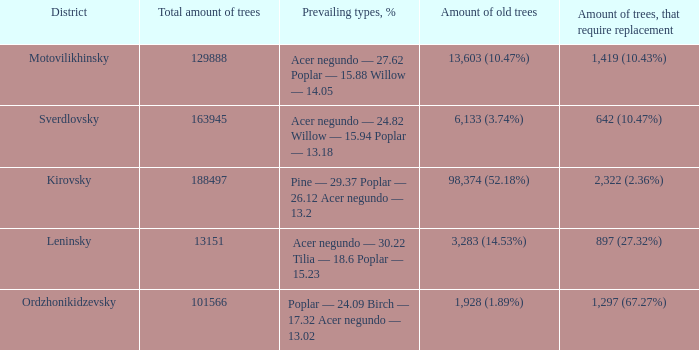Could you parse the entire table as a dict? {'header': ['District', 'Total amount of trees', 'Prevailing types, %', 'Amount of old trees', 'Amount of trees, that require replacement'], 'rows': [['Motovilikhinsky', '129888', 'Acer negundo — 27.62 Poplar — 15.88 Willow — 14.05', '13,603 (10.47%)', '1,419 (10.43%)'], ['Sverdlovsky', '163945', 'Acer negundo — 24.82 Willow — 15.94 Poplar — 13.18', '6,133 (3.74%)', '642 (10.47%)'], ['Kirovsky', '188497', 'Pine — 29.37 Poplar — 26.12 Acer negundo — 13.2', '98,374 (52.18%)', '2,322 (2.36%)'], ['Leninsky', '13151', 'Acer negundo — 30.22 Tilia — 18.6 Poplar — 15.23', '3,283 (14.53%)', '897 (27.32%)'], ['Ordzhonikidzevsky', '101566', 'Poplar — 24.09 Birch — 17.32 Acer negundo — 13.02', '1,928 (1.89%)', '1,297 (67.27%)']]} What is the amount of trees, that require replacement when the district is motovilikhinsky? 1,419 (10.43%). 